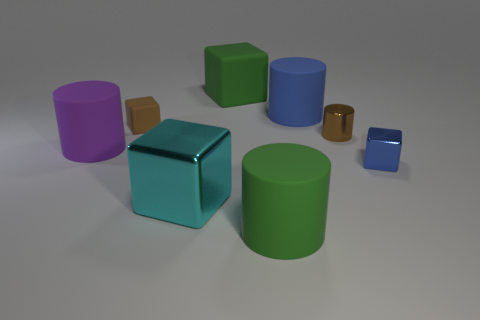Add 2 tiny metal objects. How many objects exist? 10 Subtract all green matte blocks. How many blocks are left? 3 Subtract all purple cylinders. How many cylinders are left? 3 Subtract 3 cylinders. How many cylinders are left? 1 Add 8 large red rubber things. How many large red rubber things exist? 8 Subtract 0 red balls. How many objects are left? 8 Subtract all blue cylinders. Subtract all yellow spheres. How many cylinders are left? 3 Subtract all rubber objects. Subtract all green rubber cubes. How many objects are left? 2 Add 5 green rubber things. How many green rubber things are left? 7 